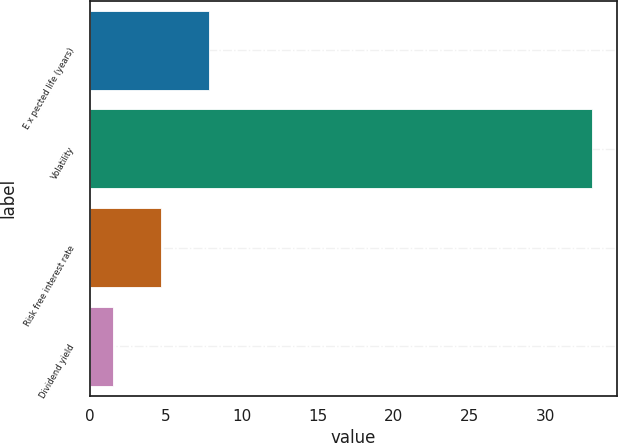Convert chart. <chart><loc_0><loc_0><loc_500><loc_500><bar_chart><fcel>E x pected life (years)<fcel>Volatility<fcel>Risk free interest rate<fcel>Dividend yield<nl><fcel>7.82<fcel>33<fcel>4.67<fcel>1.52<nl></chart> 